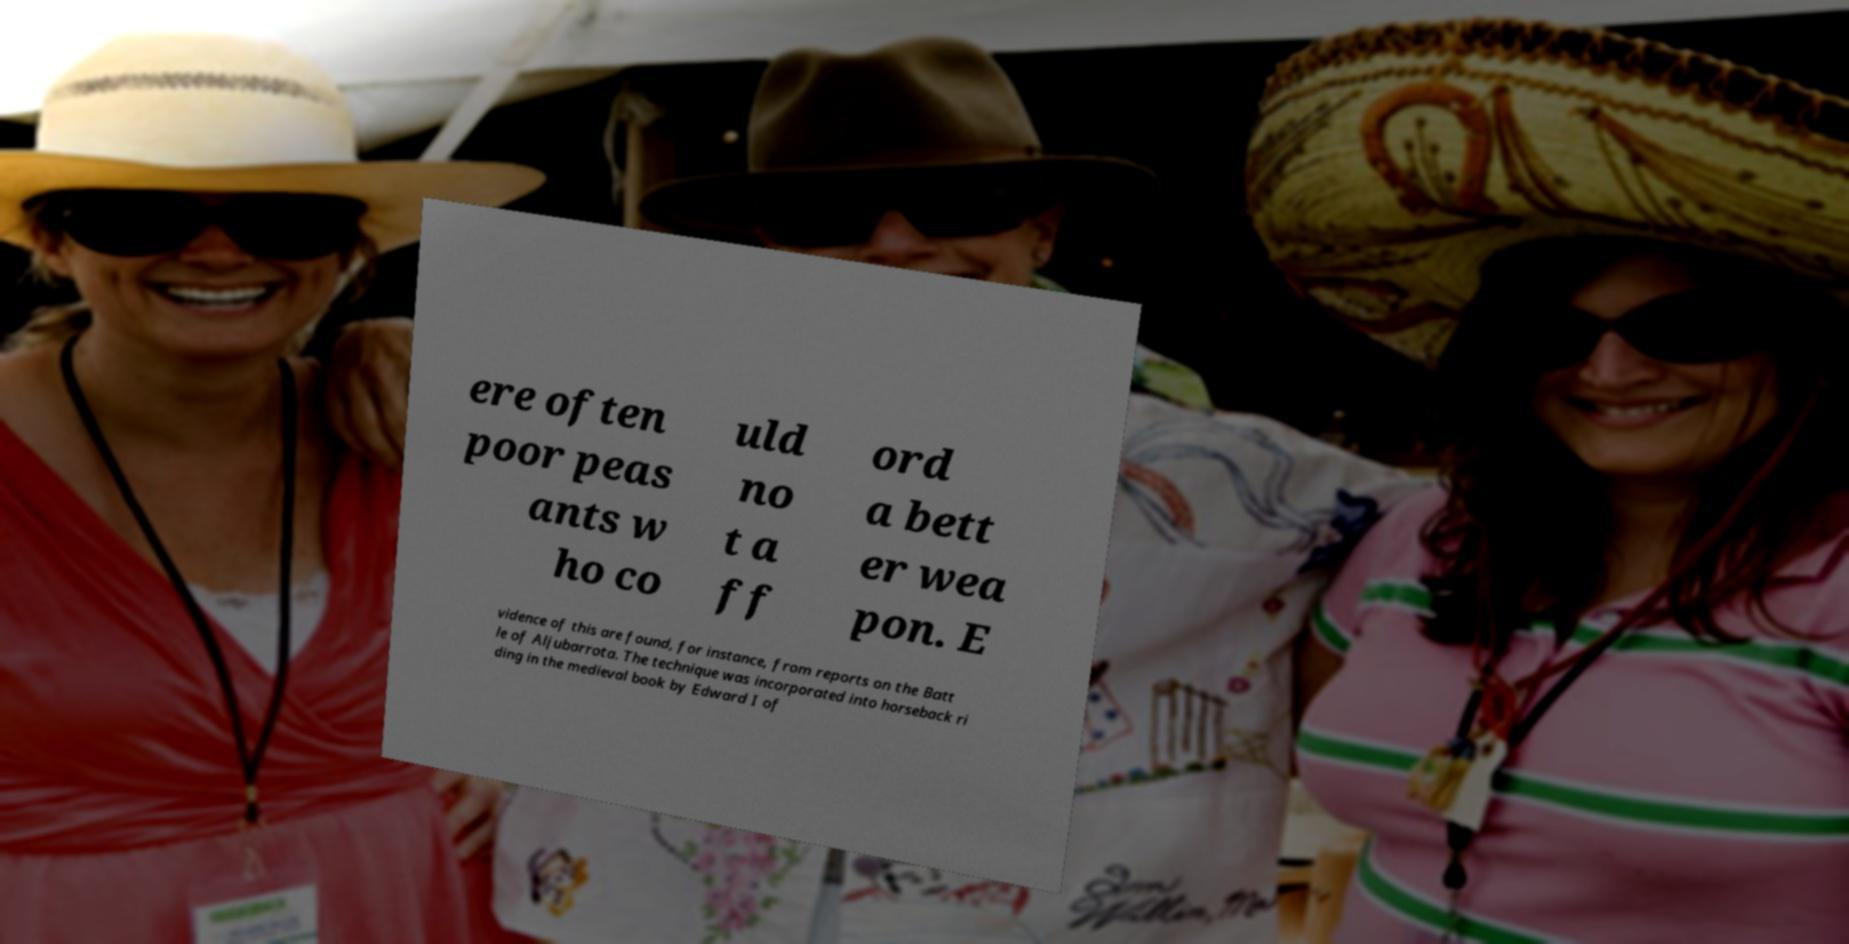There's text embedded in this image that I need extracted. Can you transcribe it verbatim? ere often poor peas ants w ho co uld no t a ff ord a bett er wea pon. E vidence of this are found, for instance, from reports on the Batt le of Aljubarrota. The technique was incorporated into horseback ri ding in the medieval book by Edward I of 